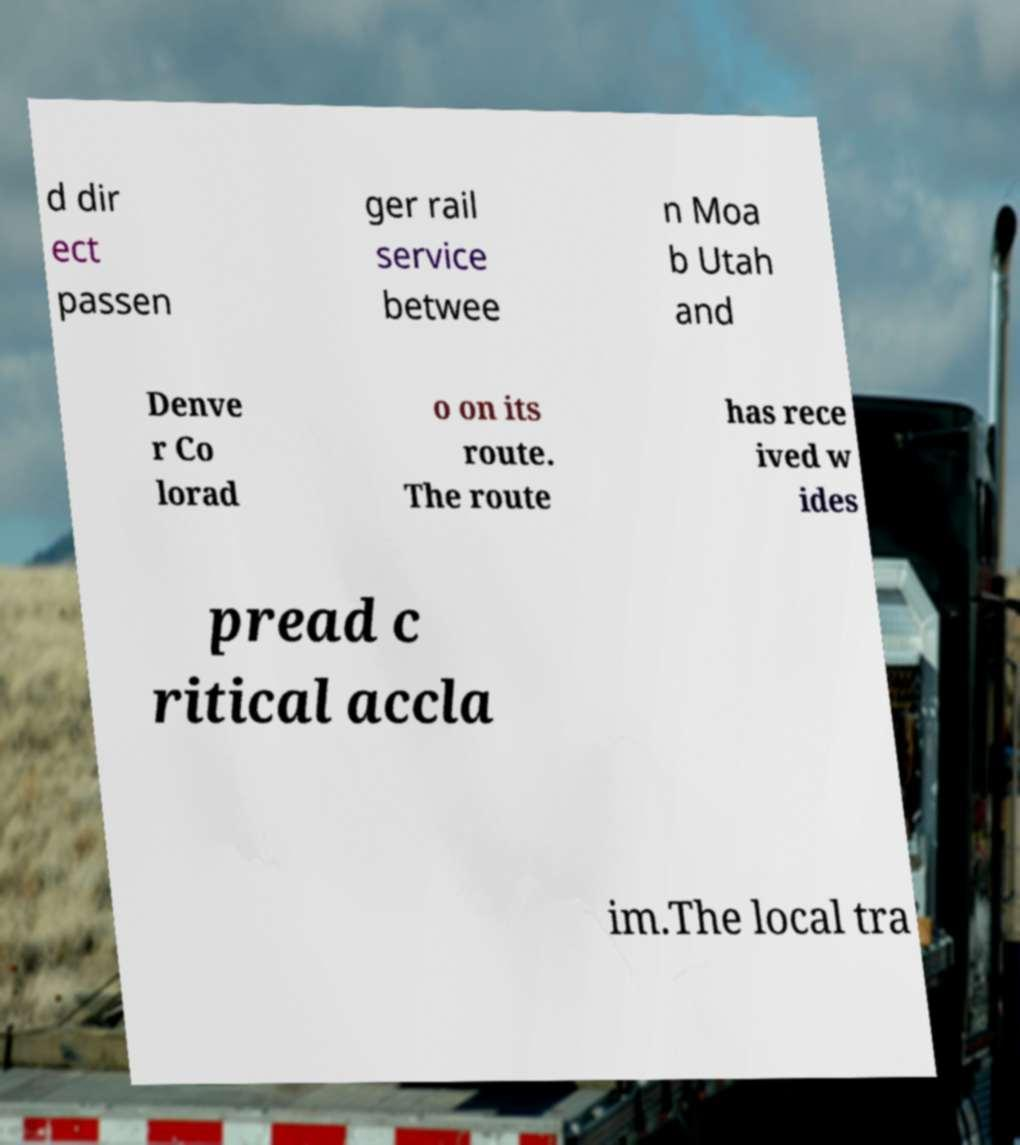Please identify and transcribe the text found in this image. d dir ect passen ger rail service betwee n Moa b Utah and Denve r Co lorad o on its route. The route has rece ived w ides pread c ritical accla im.The local tra 